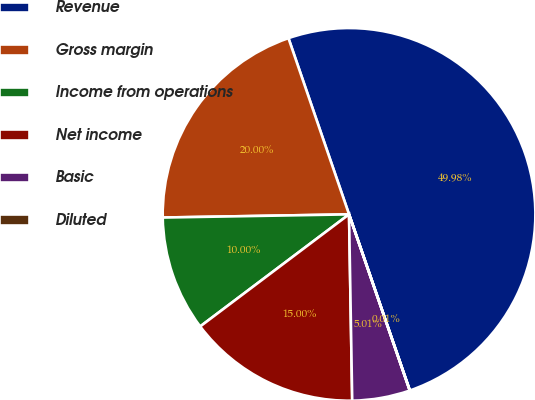Convert chart. <chart><loc_0><loc_0><loc_500><loc_500><pie_chart><fcel>Revenue<fcel>Gross margin<fcel>Income from operations<fcel>Net income<fcel>Basic<fcel>Diluted<nl><fcel>49.98%<fcel>20.0%<fcel>10.0%<fcel>15.0%<fcel>5.01%<fcel>0.01%<nl></chart> 